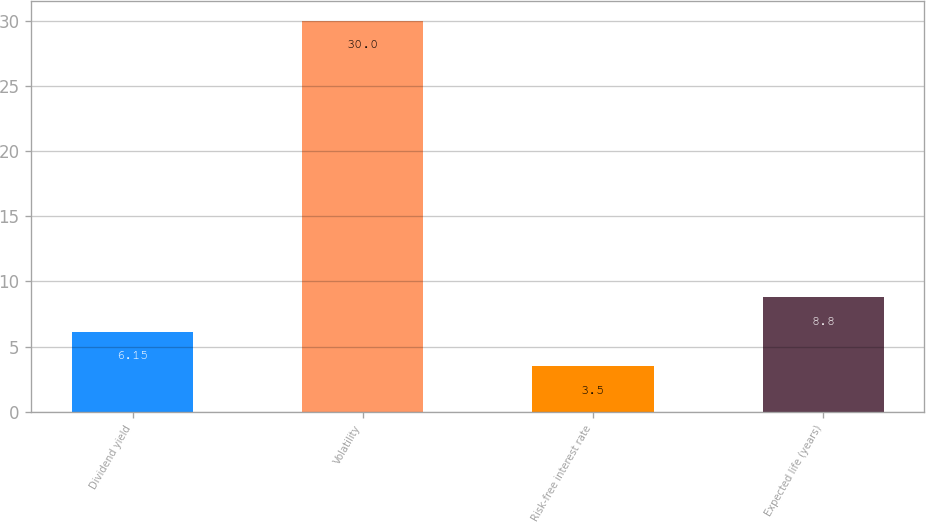Convert chart to OTSL. <chart><loc_0><loc_0><loc_500><loc_500><bar_chart><fcel>Dividend yield<fcel>Volatility<fcel>Risk-free interest rate<fcel>Expected life (years)<nl><fcel>6.15<fcel>30<fcel>3.5<fcel>8.8<nl></chart> 